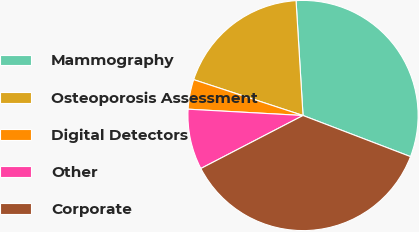Convert chart. <chart><loc_0><loc_0><loc_500><loc_500><pie_chart><fcel>Mammography<fcel>Osteoporosis Assessment<fcel>Digital Detectors<fcel>Other<fcel>Corporate<nl><fcel>31.78%<fcel>18.99%<fcel>4.17%<fcel>8.49%<fcel>36.57%<nl></chart> 